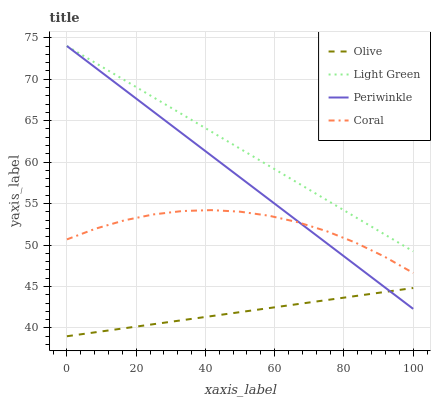Does Olive have the minimum area under the curve?
Answer yes or no. Yes. Does Light Green have the maximum area under the curve?
Answer yes or no. Yes. Does Coral have the minimum area under the curve?
Answer yes or no. No. Does Coral have the maximum area under the curve?
Answer yes or no. No. Is Periwinkle the smoothest?
Answer yes or no. Yes. Is Coral the roughest?
Answer yes or no. Yes. Is Coral the smoothest?
Answer yes or no. No. Is Periwinkle the roughest?
Answer yes or no. No. Does Olive have the lowest value?
Answer yes or no. Yes. Does Coral have the lowest value?
Answer yes or no. No. Does Light Green have the highest value?
Answer yes or no. Yes. Does Coral have the highest value?
Answer yes or no. No. Is Coral less than Light Green?
Answer yes or no. Yes. Is Light Green greater than Olive?
Answer yes or no. Yes. Does Coral intersect Periwinkle?
Answer yes or no. Yes. Is Coral less than Periwinkle?
Answer yes or no. No. Is Coral greater than Periwinkle?
Answer yes or no. No. Does Coral intersect Light Green?
Answer yes or no. No. 